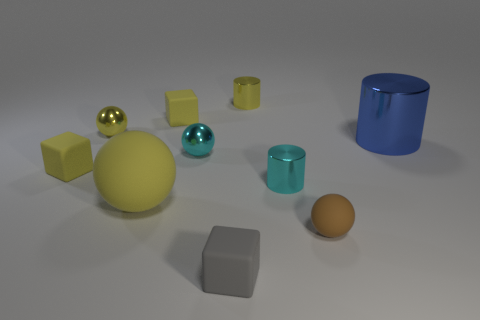Subtract all brown matte spheres. How many spheres are left? 3 Subtract all cylinders. How many objects are left? 7 Subtract all big red matte blocks. Subtract all small yellow metallic cylinders. How many objects are left? 9 Add 1 blue objects. How many blue objects are left? 2 Add 9 large red shiny cylinders. How many large red shiny cylinders exist? 9 Subtract 0 red cylinders. How many objects are left? 10 